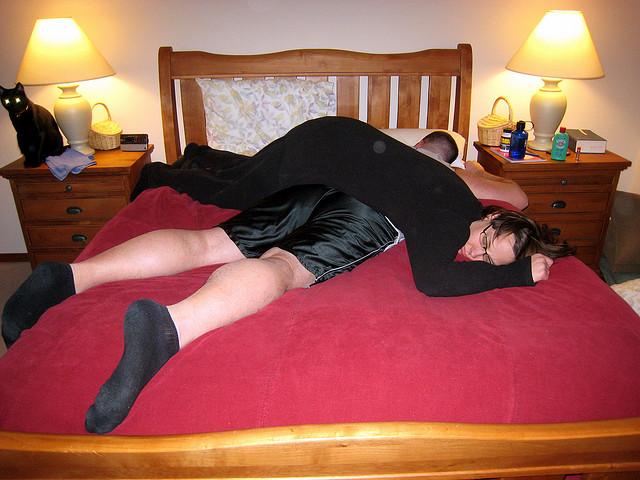What color is the blanket on the bed?
Quick response, please. Red. What animal is sitting down in this picture?
Quick response, please. Cat. What the person on the bed a woman?
Concise answer only. Yes. 